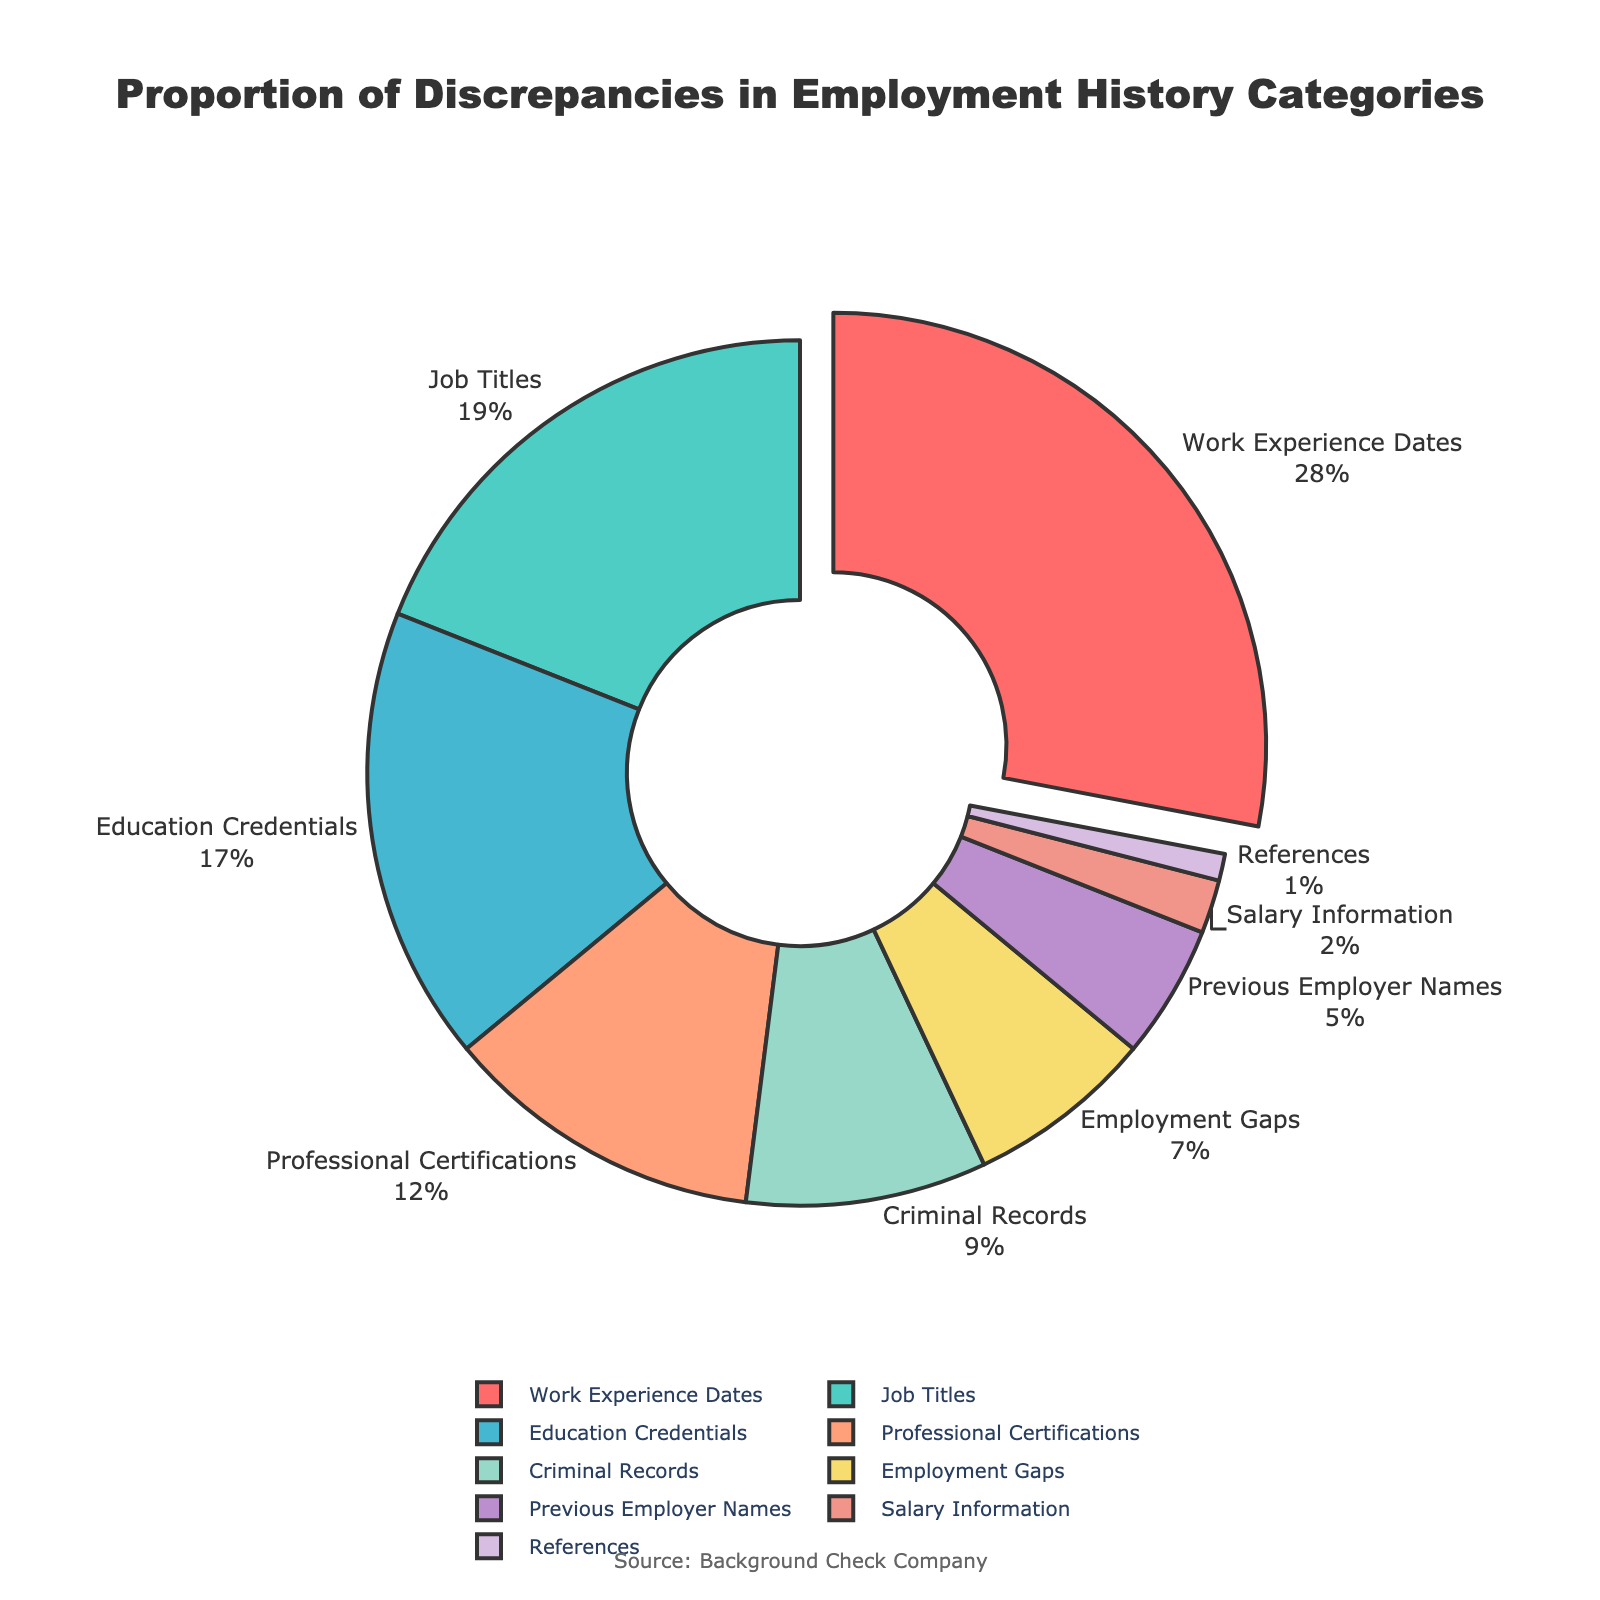What's the percentage of discrepancies in Work Experience Dates? The pie chart shows the categories of discrepancies and their percentages. Work Experience Dates has a percentage labeled next to it.
Answer: 28% Which category has the lowest percentage of discrepancies? The pie chart has the categories listed with their corresponding percentages. The category with the smallest percentage is References.
Answer: References What is the combined percentage of discrepancies in Job Titles and Education Credentials? To find the combined percentage, sum the percentages of Job Titles and Education Credentials. The pie chart shows Job Titles at 19% and Education Credentials at 17%. 19% + 17% = 36%.
Answer: 36% How does the percentage of discrepancies in Professional Certifications compare to Employment Gaps? The pie chart shows percentages for each category. Professional Certifications are at 12%, and Employment Gaps are at 7%. 12% is greater than 7%.
Answer: Professional Certifications > Employment Gaps If you combine the percentages of the three least frequent categories, what is the total? The three least frequent categories are Salary Information (2%), References (1%), and Previous Employer Names (5%). Summing these percentages gives: 2% + 1% + 5% = 8%.
Answer: 8% Which two categories have the closest percentage of discrepancies? Compare the percentages of each category to identify the two closest values. Job Titles (19%) and Education Credentials (17%) are the closest.
Answer: Job Titles and Education Credentials What proportion of discrepancies are related to Criminal Records compared to Work Experience Dates? The pie chart shows Criminal Records at 9% and Work Experience Dates at 28%. Calculate the proportion: 9% / 28% = 0.321.
Answer: 0.321 What is the difference in the percentage of discrepancies between Job Titles and Professional Certifications? The pie chart shows Job Titles at 19% and Professional Certifications at 12%. To find the difference, subtract 12% from 19%: 19% - 12% = 7%.
Answer: 7% What is the percentage of discrepancies in categories related to education (Education Credentials and Professional Certifications)? Sum the percentages of Education Credentials and Professional Certifications. The pie chart shows Education Credentials at 17% and Professional Certifications at 12%. 17% + 12% = 29%.
Answer: 29% 